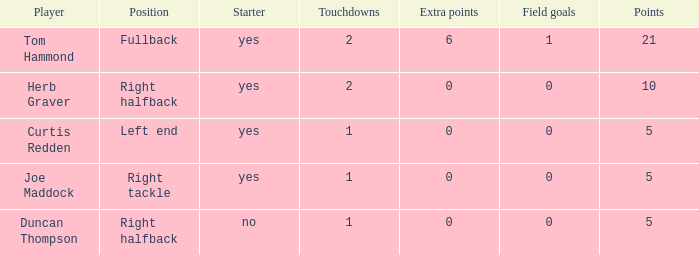Name the number of points for field goals being 1 1.0. 